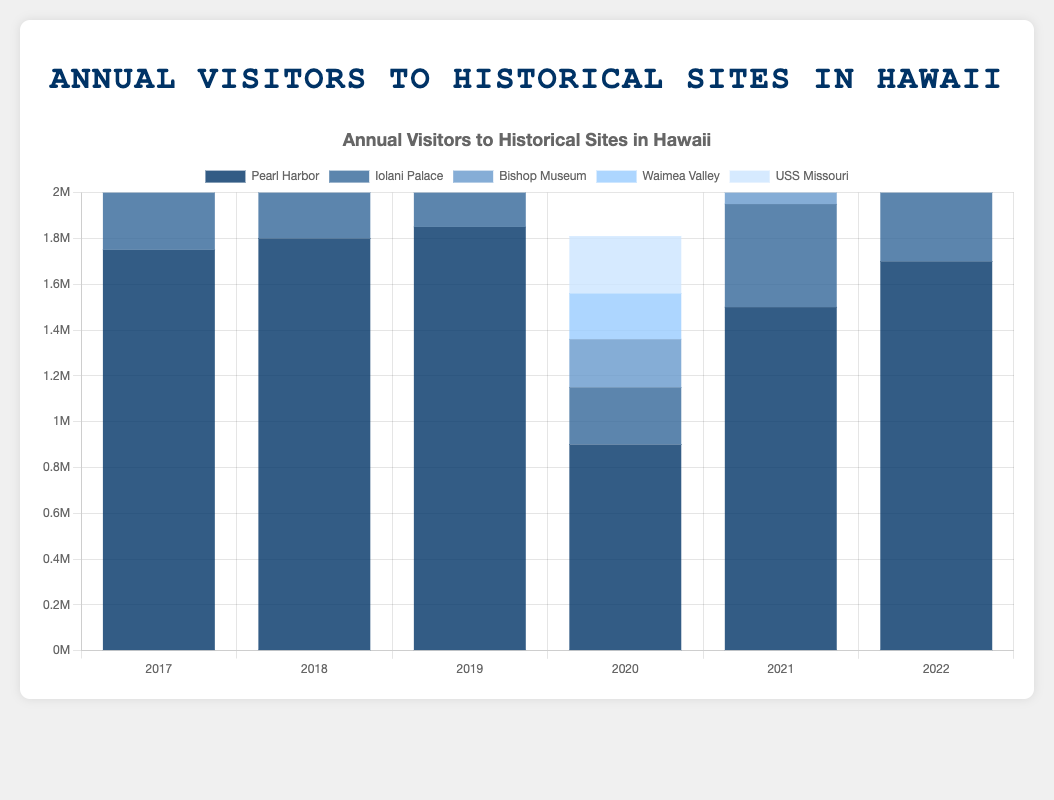What was the total number of visitors to Pearl Harbor in the years 2019 and 2020 combined? Add the number of visitors to Pearl Harbor in 2019 and 2020: 1,850,000 + 900,000 = 2,750,000
Answer: 2,750,000 Which historical site had the lowest number of visitors in 2020? Compare the visitor numbers for different sites in 2020: Pearl Harbor (900,000), Iolani Palace (250,000), Bishop Museum (210,000), Waimea Valley (200,000), and USS Missouri (250,000). Waimea Valley had the lowest number of visitors.
Answer: Waimea Valley Did the Bishop Museum see an increase or decrease in visitors from 2018 to 2019? By how many? Subtract the number of visitors in 2018 from 2019: 440,000 - 430,000 = 10,000. The Bishop Museum saw an increase of 10,000 visitors.
Answer: Increase by 10,000 How did the number of visitors to Iolani Palace in 2021 compare to the number in 2020? Compare the visitor numbers: 2020 (250,000) and 2021 (450,000). Iolani Palace saw an increase of 200,000 visitors in 2021.
Answer: Increase by 200,000 What is the average number of annual visitors to Waimea Valley over the period from 2017 to 2022? Sum up the annual visitors from 2017 to 2022 and divide by the number of years: (390,000 + 400,000 + 410,000 + 200,000 + 350,000 + 370,000) / 6 = 2,120,000 / 6 ≈ 353,333
Answer: 353,333 Which year saw the highest number of total visitors across all five historical sites? Calculate the total visitors for each year by summing up the visitors to all sites. 2017: 1750000 + 520000 + 420000 + 390000 + 530000 = 3,610,000; 2018: 1800000 + 530000 + 430000 + 400000 + 540000 = 3,710,000; 2019: 1850000 + 540000 + 440000 + 410000 + 550000 = 3,790,000; 2020: 900000 + 250000 + 210000 + 200000 + 250000 = 1,810,000; 2021: 1500000 + 450000 + 370000 + 350000 + 500000 = 3,370,000; 2022: 1700000 + 500000 + 400000 + 370000 + 520000 = 3,590,000. The highest total is in 2019 with 3,790,000 visitors.
Answer: 2019 What was the percent change in visitors to Pearl Harbor from 2019 to 2020? Calculate the percent change: (New Value - Old Value) / Old Value * 100. So, (900,000 - 1,850,000) / 1,850,000 * 100 ≈ -51.35%
Answer: -51.35% By how much did the number of visitors to the USS Missouri increase from 2020 to 2022? Subtract the number of visitors in 2020 from the number in 2022: 520,000 - 250,000 = 270,000
Answer: 270,000 Which color represents the bar for the Bishop Museum in the chart? Identify the color corresponding to the Bishop Museum bar in the legend, which is described as "light blue".
Answer: Light blue What is the total number of visitors to Iolani Palace from 2017 to 2022? Sum up the annual visitors: 520,000 + 530,000 + 540,000 + 250,000 + 450,000 + 500,000 = 2,790,000
Answer: 2,790,000 